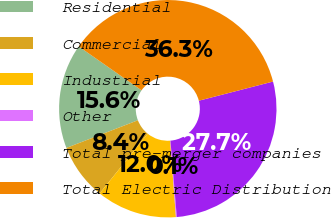Convert chart to OTSL. <chart><loc_0><loc_0><loc_500><loc_500><pie_chart><fcel>Residential<fcel>Commercial<fcel>Industrial<fcel>Other<fcel>Total pre-merger companies<fcel>Total Electric Distribution<nl><fcel>15.58%<fcel>8.35%<fcel>11.97%<fcel>0.13%<fcel>27.7%<fcel>36.27%<nl></chart> 